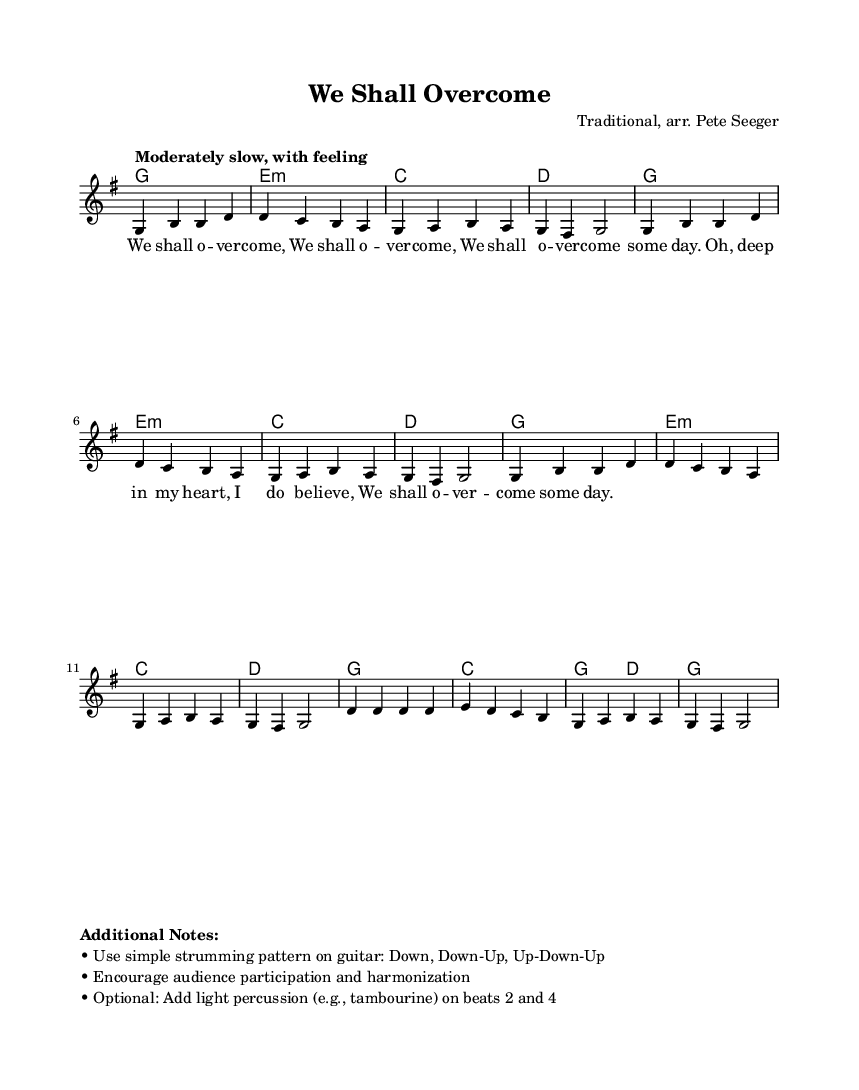What is the key signature of this music? The key signature is indicated by the symbols present in the beginning of the staff. In this case, there are no sharps or flats, so it represents the key of G major.
Answer: G major What is the time signature of this music? The time signature is shown at the beginning of the sheet music as 4/4, which indicates that there are four beats in each measure and a quarter note gets one beat.
Answer: 4/4 What is the tempo marking for this song? The tempo marking is found above the staff, reading "Moderately slow, with feeling," which provides guidance on how the piece should be played in terms of speed and expression.
Answer: Moderately slow How many measures are in the melody section? To determine the number of measures, count each group of notes and rests between the vertical lines in the sheet music. The melody section contains a total of eight measures.
Answer: Eight What is the first lyric line of the song? The first lyric line can be found beneath the melody notes and reads "We shall o -- ver -- come," which is the opening phrase of the song.
Answer: We shall o -- ver -- come Which instrument is primarily featured in this arrangement? The sheet music indicates a staff with a voice, suggesting that this arrangement is primarily for vocal performance. However, it can also be accompanied by instruments like guitar and percussion.
Answer: Voice What performance practice is suggested for audience participation? The additional notes indicate that audience participation and harmonization should be encouraged, meaning that singers are invited to join in and sing along throughout the performance.
Answer: Encouraged participation 